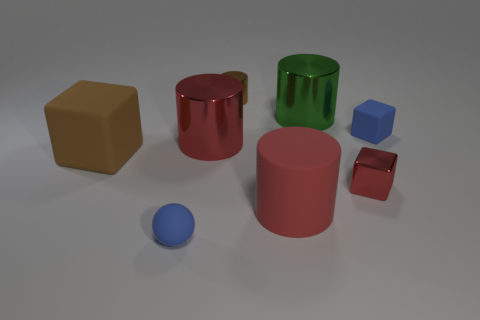What number of large red objects have the same shape as the brown metallic object?
Your response must be concise. 2. What shape is the small red thing?
Provide a short and direct response. Cube. Is the number of blue spheres behind the brown cylinder the same as the number of tiny blocks?
Offer a terse response. No. Is the big red cylinder that is behind the red cube made of the same material as the large green thing?
Offer a very short reply. Yes. Is the number of red shiny things that are on the left side of the small blue ball less than the number of tiny blocks?
Keep it short and to the point. Yes. How many shiny things are brown things or blue spheres?
Your answer should be compact. 1. Do the sphere and the small matte block have the same color?
Provide a succinct answer. Yes. Are there any other things of the same color as the rubber ball?
Offer a terse response. Yes. There is a red metallic object that is to the left of the red rubber cylinder; is its shape the same as the large red object in front of the red cube?
Offer a very short reply. Yes. What number of things are either tiny rubber balls or small things that are right of the big red rubber cylinder?
Offer a terse response. 3. 